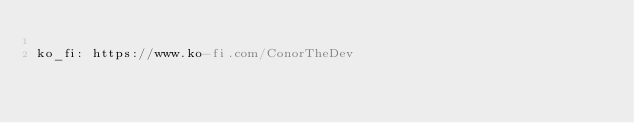Convert code to text. <code><loc_0><loc_0><loc_500><loc_500><_YAML_>
ko_fi: https://www.ko-fi.com/ConorTheDev
</code> 